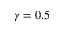<formula> <loc_0><loc_0><loc_500><loc_500>\gamma = 0 . 5</formula> 